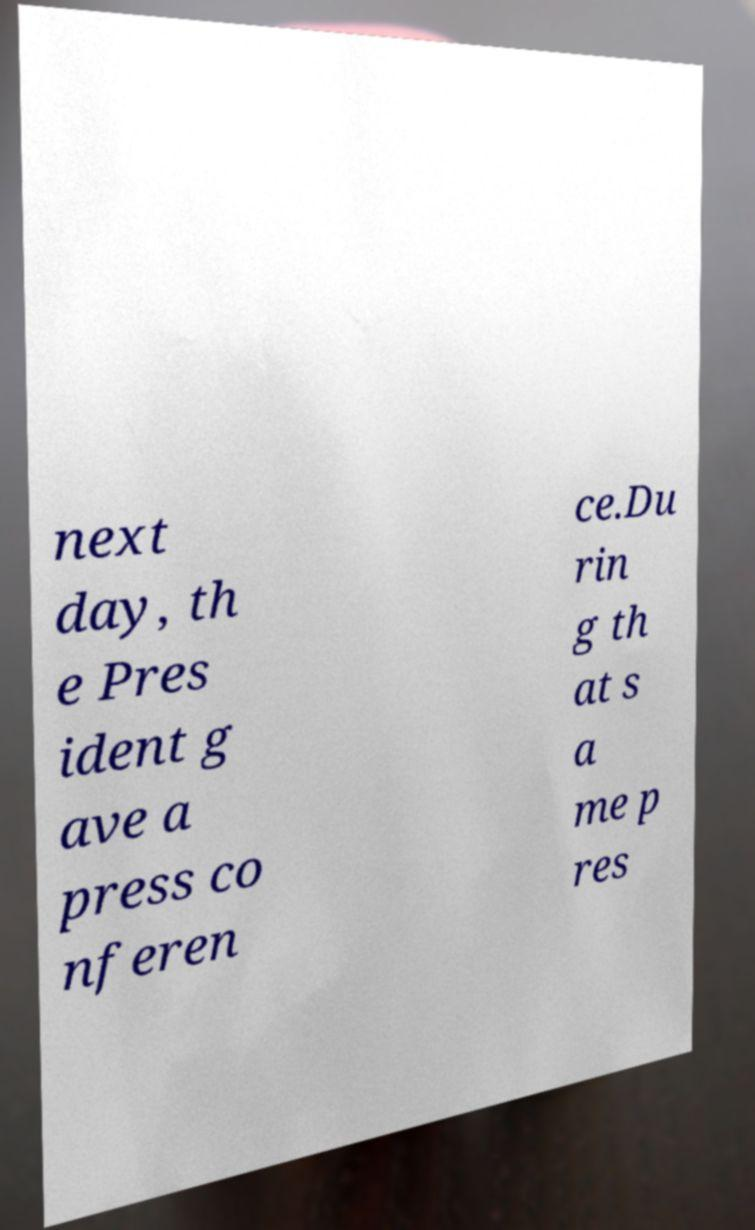Could you assist in decoding the text presented in this image and type it out clearly? next day, th e Pres ident g ave a press co nferen ce.Du rin g th at s a me p res 